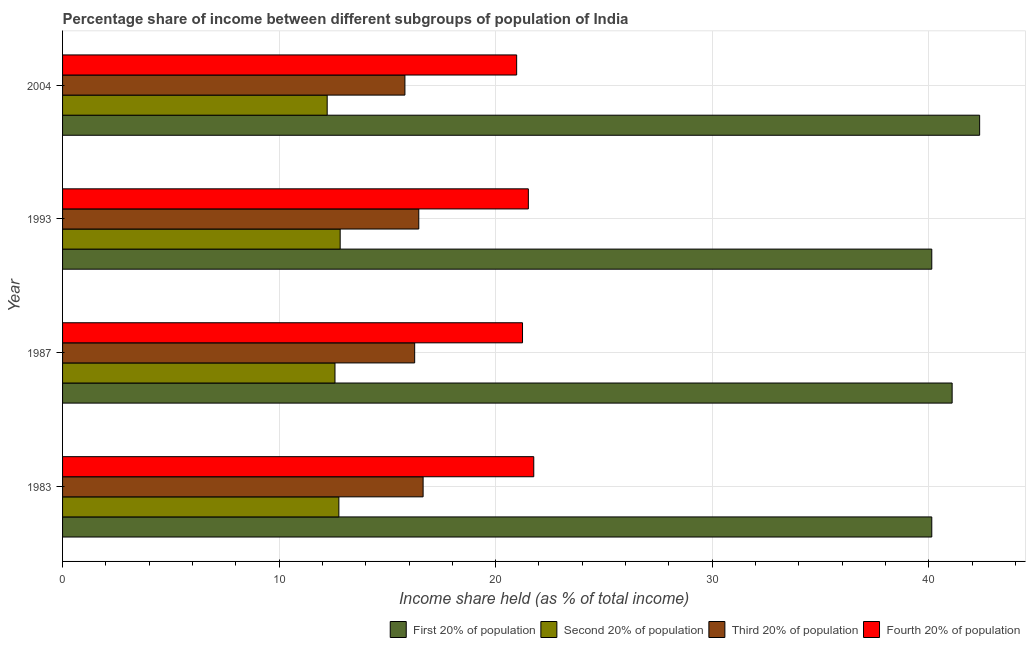Are the number of bars per tick equal to the number of legend labels?
Keep it short and to the point. Yes. How many bars are there on the 1st tick from the top?
Offer a very short reply. 4. What is the label of the 4th group of bars from the top?
Keep it short and to the point. 1983. What is the share of the income held by fourth 20% of the population in 2004?
Your answer should be compact. 20.97. Across all years, what is the maximum share of the income held by first 20% of the population?
Make the answer very short. 42.35. Across all years, what is the minimum share of the income held by second 20% of the population?
Ensure brevity in your answer.  12.22. In which year was the share of the income held by fourth 20% of the population minimum?
Your answer should be compact. 2004. What is the total share of the income held by second 20% of the population in the graph?
Offer a terse response. 50.38. What is the difference between the share of the income held by fourth 20% of the population in 1987 and the share of the income held by second 20% of the population in 2004?
Keep it short and to the point. 9.02. What is the average share of the income held by fourth 20% of the population per year?
Make the answer very short. 21.37. In the year 1987, what is the difference between the share of the income held by fourth 20% of the population and share of the income held by second 20% of the population?
Your response must be concise. 8.66. In how many years, is the share of the income held by fourth 20% of the population greater than 22 %?
Provide a short and direct response. 0. What is the ratio of the share of the income held by fourth 20% of the population in 1983 to that in 2004?
Offer a very short reply. 1.04. What is the difference between the highest and the lowest share of the income held by fourth 20% of the population?
Offer a very short reply. 0.79. In how many years, is the share of the income held by first 20% of the population greater than the average share of the income held by first 20% of the population taken over all years?
Your answer should be compact. 2. Is it the case that in every year, the sum of the share of the income held by fourth 20% of the population and share of the income held by second 20% of the population is greater than the sum of share of the income held by first 20% of the population and share of the income held by third 20% of the population?
Give a very brief answer. Yes. What does the 4th bar from the top in 2004 represents?
Provide a succinct answer. First 20% of population. What does the 3rd bar from the bottom in 2004 represents?
Give a very brief answer. Third 20% of population. Is it the case that in every year, the sum of the share of the income held by first 20% of the population and share of the income held by second 20% of the population is greater than the share of the income held by third 20% of the population?
Ensure brevity in your answer.  Yes. How many years are there in the graph?
Give a very brief answer. 4. What is the difference between two consecutive major ticks on the X-axis?
Ensure brevity in your answer.  10. Does the graph contain any zero values?
Provide a succinct answer. No. Does the graph contain grids?
Give a very brief answer. Yes. Where does the legend appear in the graph?
Make the answer very short. Bottom right. What is the title of the graph?
Provide a succinct answer. Percentage share of income between different subgroups of population of India. Does "Switzerland" appear as one of the legend labels in the graph?
Ensure brevity in your answer.  No. What is the label or title of the X-axis?
Your answer should be compact. Income share held (as % of total income). What is the label or title of the Y-axis?
Provide a succinct answer. Year. What is the Income share held (as % of total income) of First 20% of population in 1983?
Ensure brevity in your answer.  40.14. What is the Income share held (as % of total income) of Second 20% of population in 1983?
Give a very brief answer. 12.76. What is the Income share held (as % of total income) in Third 20% of population in 1983?
Give a very brief answer. 16.65. What is the Income share held (as % of total income) of Fourth 20% of population in 1983?
Your response must be concise. 21.76. What is the Income share held (as % of total income) in First 20% of population in 1987?
Offer a terse response. 41.08. What is the Income share held (as % of total income) in Second 20% of population in 1987?
Your answer should be very brief. 12.58. What is the Income share held (as % of total income) of Third 20% of population in 1987?
Your response must be concise. 16.26. What is the Income share held (as % of total income) in Fourth 20% of population in 1987?
Your response must be concise. 21.24. What is the Income share held (as % of total income) of First 20% of population in 1993?
Provide a succinct answer. 40.14. What is the Income share held (as % of total income) of Second 20% of population in 1993?
Provide a succinct answer. 12.82. What is the Income share held (as % of total income) in Third 20% of population in 1993?
Your answer should be very brief. 16.45. What is the Income share held (as % of total income) in Fourth 20% of population in 1993?
Offer a terse response. 21.51. What is the Income share held (as % of total income) of First 20% of population in 2004?
Ensure brevity in your answer.  42.35. What is the Income share held (as % of total income) in Second 20% of population in 2004?
Provide a succinct answer. 12.22. What is the Income share held (as % of total income) in Third 20% of population in 2004?
Offer a very short reply. 15.81. What is the Income share held (as % of total income) in Fourth 20% of population in 2004?
Your answer should be very brief. 20.97. Across all years, what is the maximum Income share held (as % of total income) of First 20% of population?
Offer a terse response. 42.35. Across all years, what is the maximum Income share held (as % of total income) in Second 20% of population?
Your response must be concise. 12.82. Across all years, what is the maximum Income share held (as % of total income) of Third 20% of population?
Offer a very short reply. 16.65. Across all years, what is the maximum Income share held (as % of total income) of Fourth 20% of population?
Your response must be concise. 21.76. Across all years, what is the minimum Income share held (as % of total income) of First 20% of population?
Make the answer very short. 40.14. Across all years, what is the minimum Income share held (as % of total income) in Second 20% of population?
Provide a succinct answer. 12.22. Across all years, what is the minimum Income share held (as % of total income) of Third 20% of population?
Provide a succinct answer. 15.81. Across all years, what is the minimum Income share held (as % of total income) in Fourth 20% of population?
Keep it short and to the point. 20.97. What is the total Income share held (as % of total income) in First 20% of population in the graph?
Your response must be concise. 163.71. What is the total Income share held (as % of total income) in Second 20% of population in the graph?
Give a very brief answer. 50.38. What is the total Income share held (as % of total income) in Third 20% of population in the graph?
Your response must be concise. 65.17. What is the total Income share held (as % of total income) in Fourth 20% of population in the graph?
Keep it short and to the point. 85.48. What is the difference between the Income share held (as % of total income) in First 20% of population in 1983 and that in 1987?
Your response must be concise. -0.94. What is the difference between the Income share held (as % of total income) of Second 20% of population in 1983 and that in 1987?
Your answer should be very brief. 0.18. What is the difference between the Income share held (as % of total income) of Third 20% of population in 1983 and that in 1987?
Keep it short and to the point. 0.39. What is the difference between the Income share held (as % of total income) in Fourth 20% of population in 1983 and that in 1987?
Provide a succinct answer. 0.52. What is the difference between the Income share held (as % of total income) of First 20% of population in 1983 and that in 1993?
Your answer should be compact. 0. What is the difference between the Income share held (as % of total income) in Second 20% of population in 1983 and that in 1993?
Offer a terse response. -0.06. What is the difference between the Income share held (as % of total income) of Fourth 20% of population in 1983 and that in 1993?
Your response must be concise. 0.25. What is the difference between the Income share held (as % of total income) in First 20% of population in 1983 and that in 2004?
Your response must be concise. -2.21. What is the difference between the Income share held (as % of total income) of Second 20% of population in 1983 and that in 2004?
Your response must be concise. 0.54. What is the difference between the Income share held (as % of total income) in Third 20% of population in 1983 and that in 2004?
Offer a very short reply. 0.84. What is the difference between the Income share held (as % of total income) of Fourth 20% of population in 1983 and that in 2004?
Your response must be concise. 0.79. What is the difference between the Income share held (as % of total income) in First 20% of population in 1987 and that in 1993?
Your answer should be very brief. 0.94. What is the difference between the Income share held (as % of total income) of Second 20% of population in 1987 and that in 1993?
Your answer should be compact. -0.24. What is the difference between the Income share held (as % of total income) in Third 20% of population in 1987 and that in 1993?
Make the answer very short. -0.19. What is the difference between the Income share held (as % of total income) of Fourth 20% of population in 1987 and that in 1993?
Offer a very short reply. -0.27. What is the difference between the Income share held (as % of total income) in First 20% of population in 1987 and that in 2004?
Your response must be concise. -1.27. What is the difference between the Income share held (as % of total income) in Second 20% of population in 1987 and that in 2004?
Offer a very short reply. 0.36. What is the difference between the Income share held (as % of total income) of Third 20% of population in 1987 and that in 2004?
Make the answer very short. 0.45. What is the difference between the Income share held (as % of total income) of Fourth 20% of population in 1987 and that in 2004?
Offer a very short reply. 0.27. What is the difference between the Income share held (as % of total income) of First 20% of population in 1993 and that in 2004?
Ensure brevity in your answer.  -2.21. What is the difference between the Income share held (as % of total income) in Third 20% of population in 1993 and that in 2004?
Your answer should be very brief. 0.64. What is the difference between the Income share held (as % of total income) of Fourth 20% of population in 1993 and that in 2004?
Your response must be concise. 0.54. What is the difference between the Income share held (as % of total income) of First 20% of population in 1983 and the Income share held (as % of total income) of Second 20% of population in 1987?
Offer a terse response. 27.56. What is the difference between the Income share held (as % of total income) of First 20% of population in 1983 and the Income share held (as % of total income) of Third 20% of population in 1987?
Provide a short and direct response. 23.88. What is the difference between the Income share held (as % of total income) in Second 20% of population in 1983 and the Income share held (as % of total income) in Fourth 20% of population in 1987?
Give a very brief answer. -8.48. What is the difference between the Income share held (as % of total income) in Third 20% of population in 1983 and the Income share held (as % of total income) in Fourth 20% of population in 1987?
Give a very brief answer. -4.59. What is the difference between the Income share held (as % of total income) in First 20% of population in 1983 and the Income share held (as % of total income) in Second 20% of population in 1993?
Provide a short and direct response. 27.32. What is the difference between the Income share held (as % of total income) of First 20% of population in 1983 and the Income share held (as % of total income) of Third 20% of population in 1993?
Ensure brevity in your answer.  23.69. What is the difference between the Income share held (as % of total income) of First 20% of population in 1983 and the Income share held (as % of total income) of Fourth 20% of population in 1993?
Ensure brevity in your answer.  18.63. What is the difference between the Income share held (as % of total income) of Second 20% of population in 1983 and the Income share held (as % of total income) of Third 20% of population in 1993?
Keep it short and to the point. -3.69. What is the difference between the Income share held (as % of total income) in Second 20% of population in 1983 and the Income share held (as % of total income) in Fourth 20% of population in 1993?
Your response must be concise. -8.75. What is the difference between the Income share held (as % of total income) in Third 20% of population in 1983 and the Income share held (as % of total income) in Fourth 20% of population in 1993?
Provide a succinct answer. -4.86. What is the difference between the Income share held (as % of total income) of First 20% of population in 1983 and the Income share held (as % of total income) of Second 20% of population in 2004?
Make the answer very short. 27.92. What is the difference between the Income share held (as % of total income) in First 20% of population in 1983 and the Income share held (as % of total income) in Third 20% of population in 2004?
Ensure brevity in your answer.  24.33. What is the difference between the Income share held (as % of total income) in First 20% of population in 1983 and the Income share held (as % of total income) in Fourth 20% of population in 2004?
Make the answer very short. 19.17. What is the difference between the Income share held (as % of total income) of Second 20% of population in 1983 and the Income share held (as % of total income) of Third 20% of population in 2004?
Offer a very short reply. -3.05. What is the difference between the Income share held (as % of total income) of Second 20% of population in 1983 and the Income share held (as % of total income) of Fourth 20% of population in 2004?
Provide a short and direct response. -8.21. What is the difference between the Income share held (as % of total income) of Third 20% of population in 1983 and the Income share held (as % of total income) of Fourth 20% of population in 2004?
Your answer should be very brief. -4.32. What is the difference between the Income share held (as % of total income) in First 20% of population in 1987 and the Income share held (as % of total income) in Second 20% of population in 1993?
Your answer should be compact. 28.26. What is the difference between the Income share held (as % of total income) in First 20% of population in 1987 and the Income share held (as % of total income) in Third 20% of population in 1993?
Give a very brief answer. 24.63. What is the difference between the Income share held (as % of total income) in First 20% of population in 1987 and the Income share held (as % of total income) in Fourth 20% of population in 1993?
Offer a terse response. 19.57. What is the difference between the Income share held (as % of total income) of Second 20% of population in 1987 and the Income share held (as % of total income) of Third 20% of population in 1993?
Make the answer very short. -3.87. What is the difference between the Income share held (as % of total income) of Second 20% of population in 1987 and the Income share held (as % of total income) of Fourth 20% of population in 1993?
Provide a succinct answer. -8.93. What is the difference between the Income share held (as % of total income) of Third 20% of population in 1987 and the Income share held (as % of total income) of Fourth 20% of population in 1993?
Your answer should be very brief. -5.25. What is the difference between the Income share held (as % of total income) of First 20% of population in 1987 and the Income share held (as % of total income) of Second 20% of population in 2004?
Provide a short and direct response. 28.86. What is the difference between the Income share held (as % of total income) of First 20% of population in 1987 and the Income share held (as % of total income) of Third 20% of population in 2004?
Offer a very short reply. 25.27. What is the difference between the Income share held (as % of total income) in First 20% of population in 1987 and the Income share held (as % of total income) in Fourth 20% of population in 2004?
Your response must be concise. 20.11. What is the difference between the Income share held (as % of total income) of Second 20% of population in 1987 and the Income share held (as % of total income) of Third 20% of population in 2004?
Make the answer very short. -3.23. What is the difference between the Income share held (as % of total income) in Second 20% of population in 1987 and the Income share held (as % of total income) in Fourth 20% of population in 2004?
Your response must be concise. -8.39. What is the difference between the Income share held (as % of total income) in Third 20% of population in 1987 and the Income share held (as % of total income) in Fourth 20% of population in 2004?
Provide a succinct answer. -4.71. What is the difference between the Income share held (as % of total income) in First 20% of population in 1993 and the Income share held (as % of total income) in Second 20% of population in 2004?
Offer a very short reply. 27.92. What is the difference between the Income share held (as % of total income) of First 20% of population in 1993 and the Income share held (as % of total income) of Third 20% of population in 2004?
Your answer should be very brief. 24.33. What is the difference between the Income share held (as % of total income) in First 20% of population in 1993 and the Income share held (as % of total income) in Fourth 20% of population in 2004?
Give a very brief answer. 19.17. What is the difference between the Income share held (as % of total income) in Second 20% of population in 1993 and the Income share held (as % of total income) in Third 20% of population in 2004?
Provide a succinct answer. -2.99. What is the difference between the Income share held (as % of total income) of Second 20% of population in 1993 and the Income share held (as % of total income) of Fourth 20% of population in 2004?
Keep it short and to the point. -8.15. What is the difference between the Income share held (as % of total income) of Third 20% of population in 1993 and the Income share held (as % of total income) of Fourth 20% of population in 2004?
Offer a terse response. -4.52. What is the average Income share held (as % of total income) in First 20% of population per year?
Your answer should be very brief. 40.93. What is the average Income share held (as % of total income) in Second 20% of population per year?
Offer a very short reply. 12.6. What is the average Income share held (as % of total income) of Third 20% of population per year?
Ensure brevity in your answer.  16.29. What is the average Income share held (as % of total income) of Fourth 20% of population per year?
Give a very brief answer. 21.37. In the year 1983, what is the difference between the Income share held (as % of total income) in First 20% of population and Income share held (as % of total income) in Second 20% of population?
Provide a short and direct response. 27.38. In the year 1983, what is the difference between the Income share held (as % of total income) in First 20% of population and Income share held (as % of total income) in Third 20% of population?
Ensure brevity in your answer.  23.49. In the year 1983, what is the difference between the Income share held (as % of total income) of First 20% of population and Income share held (as % of total income) of Fourth 20% of population?
Your answer should be compact. 18.38. In the year 1983, what is the difference between the Income share held (as % of total income) of Second 20% of population and Income share held (as % of total income) of Third 20% of population?
Offer a terse response. -3.89. In the year 1983, what is the difference between the Income share held (as % of total income) in Third 20% of population and Income share held (as % of total income) in Fourth 20% of population?
Give a very brief answer. -5.11. In the year 1987, what is the difference between the Income share held (as % of total income) in First 20% of population and Income share held (as % of total income) in Third 20% of population?
Your answer should be very brief. 24.82. In the year 1987, what is the difference between the Income share held (as % of total income) of First 20% of population and Income share held (as % of total income) of Fourth 20% of population?
Keep it short and to the point. 19.84. In the year 1987, what is the difference between the Income share held (as % of total income) of Second 20% of population and Income share held (as % of total income) of Third 20% of population?
Make the answer very short. -3.68. In the year 1987, what is the difference between the Income share held (as % of total income) of Second 20% of population and Income share held (as % of total income) of Fourth 20% of population?
Ensure brevity in your answer.  -8.66. In the year 1987, what is the difference between the Income share held (as % of total income) in Third 20% of population and Income share held (as % of total income) in Fourth 20% of population?
Ensure brevity in your answer.  -4.98. In the year 1993, what is the difference between the Income share held (as % of total income) of First 20% of population and Income share held (as % of total income) of Second 20% of population?
Your response must be concise. 27.32. In the year 1993, what is the difference between the Income share held (as % of total income) of First 20% of population and Income share held (as % of total income) of Third 20% of population?
Provide a succinct answer. 23.69. In the year 1993, what is the difference between the Income share held (as % of total income) in First 20% of population and Income share held (as % of total income) in Fourth 20% of population?
Your response must be concise. 18.63. In the year 1993, what is the difference between the Income share held (as % of total income) of Second 20% of population and Income share held (as % of total income) of Third 20% of population?
Offer a very short reply. -3.63. In the year 1993, what is the difference between the Income share held (as % of total income) in Second 20% of population and Income share held (as % of total income) in Fourth 20% of population?
Provide a succinct answer. -8.69. In the year 1993, what is the difference between the Income share held (as % of total income) of Third 20% of population and Income share held (as % of total income) of Fourth 20% of population?
Keep it short and to the point. -5.06. In the year 2004, what is the difference between the Income share held (as % of total income) in First 20% of population and Income share held (as % of total income) in Second 20% of population?
Ensure brevity in your answer.  30.13. In the year 2004, what is the difference between the Income share held (as % of total income) of First 20% of population and Income share held (as % of total income) of Third 20% of population?
Your answer should be compact. 26.54. In the year 2004, what is the difference between the Income share held (as % of total income) of First 20% of population and Income share held (as % of total income) of Fourth 20% of population?
Make the answer very short. 21.38. In the year 2004, what is the difference between the Income share held (as % of total income) in Second 20% of population and Income share held (as % of total income) in Third 20% of population?
Keep it short and to the point. -3.59. In the year 2004, what is the difference between the Income share held (as % of total income) of Second 20% of population and Income share held (as % of total income) of Fourth 20% of population?
Ensure brevity in your answer.  -8.75. In the year 2004, what is the difference between the Income share held (as % of total income) of Third 20% of population and Income share held (as % of total income) of Fourth 20% of population?
Ensure brevity in your answer.  -5.16. What is the ratio of the Income share held (as % of total income) in First 20% of population in 1983 to that in 1987?
Keep it short and to the point. 0.98. What is the ratio of the Income share held (as % of total income) in Second 20% of population in 1983 to that in 1987?
Your answer should be very brief. 1.01. What is the ratio of the Income share held (as % of total income) of Fourth 20% of population in 1983 to that in 1987?
Provide a succinct answer. 1.02. What is the ratio of the Income share held (as % of total income) in Third 20% of population in 1983 to that in 1993?
Your answer should be very brief. 1.01. What is the ratio of the Income share held (as % of total income) in Fourth 20% of population in 1983 to that in 1993?
Make the answer very short. 1.01. What is the ratio of the Income share held (as % of total income) of First 20% of population in 1983 to that in 2004?
Offer a terse response. 0.95. What is the ratio of the Income share held (as % of total income) in Second 20% of population in 1983 to that in 2004?
Provide a succinct answer. 1.04. What is the ratio of the Income share held (as % of total income) in Third 20% of population in 1983 to that in 2004?
Ensure brevity in your answer.  1.05. What is the ratio of the Income share held (as % of total income) in Fourth 20% of population in 1983 to that in 2004?
Keep it short and to the point. 1.04. What is the ratio of the Income share held (as % of total income) of First 20% of population in 1987 to that in 1993?
Your response must be concise. 1.02. What is the ratio of the Income share held (as % of total income) of Second 20% of population in 1987 to that in 1993?
Provide a succinct answer. 0.98. What is the ratio of the Income share held (as % of total income) of Third 20% of population in 1987 to that in 1993?
Your response must be concise. 0.99. What is the ratio of the Income share held (as % of total income) in Fourth 20% of population in 1987 to that in 1993?
Offer a terse response. 0.99. What is the ratio of the Income share held (as % of total income) of Second 20% of population in 1987 to that in 2004?
Give a very brief answer. 1.03. What is the ratio of the Income share held (as % of total income) in Third 20% of population in 1987 to that in 2004?
Make the answer very short. 1.03. What is the ratio of the Income share held (as % of total income) in Fourth 20% of population in 1987 to that in 2004?
Provide a succinct answer. 1.01. What is the ratio of the Income share held (as % of total income) in First 20% of population in 1993 to that in 2004?
Your response must be concise. 0.95. What is the ratio of the Income share held (as % of total income) of Second 20% of population in 1993 to that in 2004?
Ensure brevity in your answer.  1.05. What is the ratio of the Income share held (as % of total income) in Third 20% of population in 1993 to that in 2004?
Offer a terse response. 1.04. What is the ratio of the Income share held (as % of total income) in Fourth 20% of population in 1993 to that in 2004?
Your response must be concise. 1.03. What is the difference between the highest and the second highest Income share held (as % of total income) in First 20% of population?
Provide a short and direct response. 1.27. What is the difference between the highest and the second highest Income share held (as % of total income) of Third 20% of population?
Your response must be concise. 0.2. What is the difference between the highest and the second highest Income share held (as % of total income) of Fourth 20% of population?
Offer a terse response. 0.25. What is the difference between the highest and the lowest Income share held (as % of total income) in First 20% of population?
Keep it short and to the point. 2.21. What is the difference between the highest and the lowest Income share held (as % of total income) in Third 20% of population?
Provide a short and direct response. 0.84. What is the difference between the highest and the lowest Income share held (as % of total income) in Fourth 20% of population?
Provide a succinct answer. 0.79. 